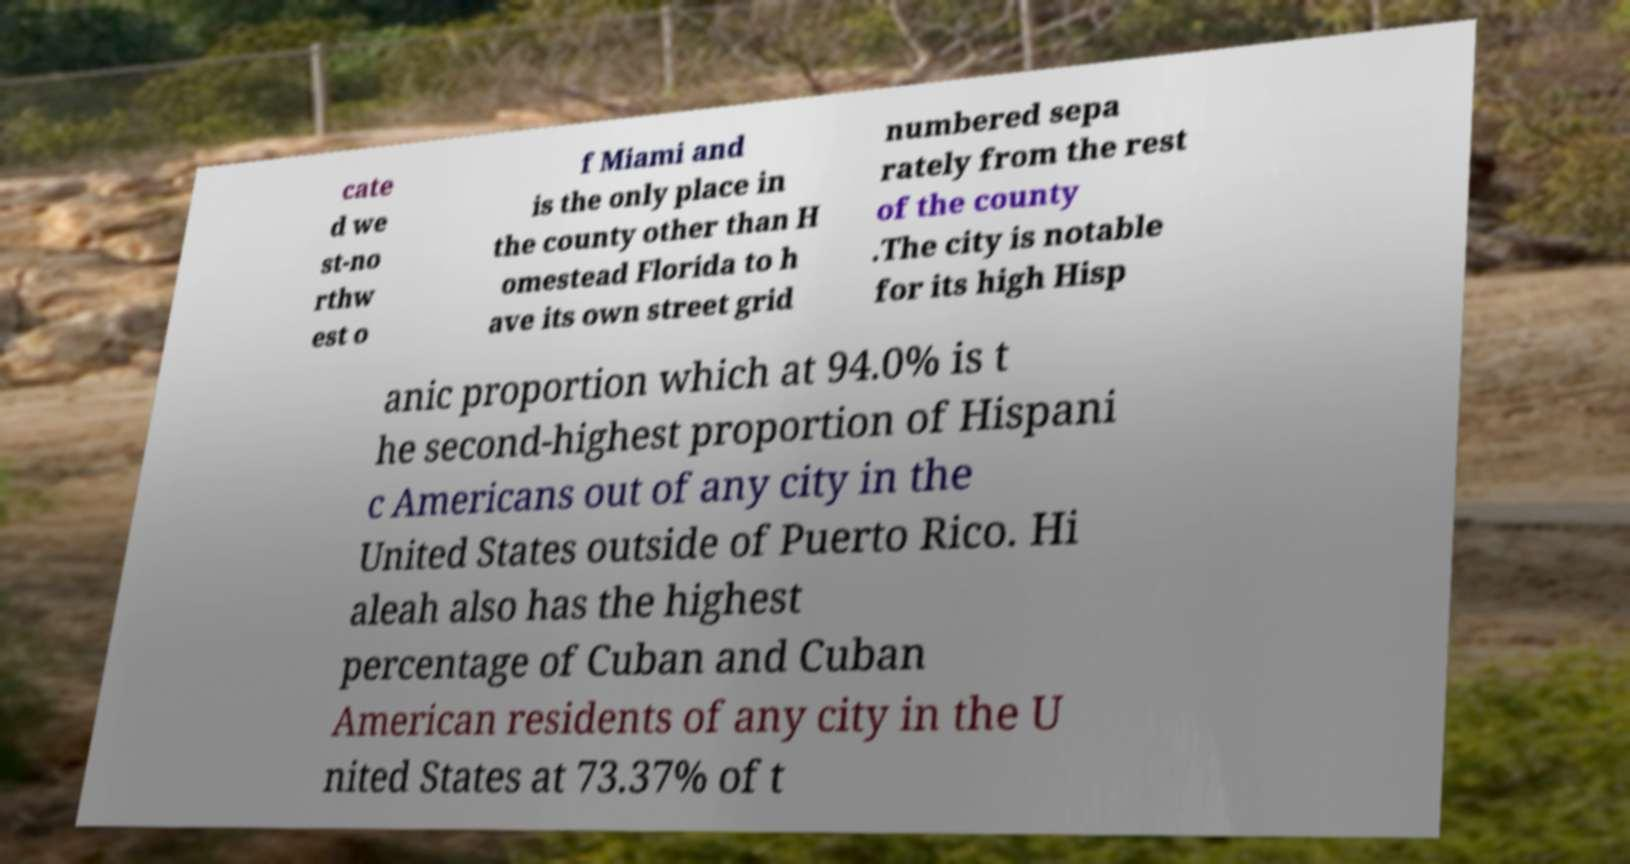What messages or text are displayed in this image? I need them in a readable, typed format. cate d we st-no rthw est o f Miami and is the only place in the county other than H omestead Florida to h ave its own street grid numbered sepa rately from the rest of the county .The city is notable for its high Hisp anic proportion which at 94.0% is t he second-highest proportion of Hispani c Americans out of any city in the United States outside of Puerto Rico. Hi aleah also has the highest percentage of Cuban and Cuban American residents of any city in the U nited States at 73.37% of t 